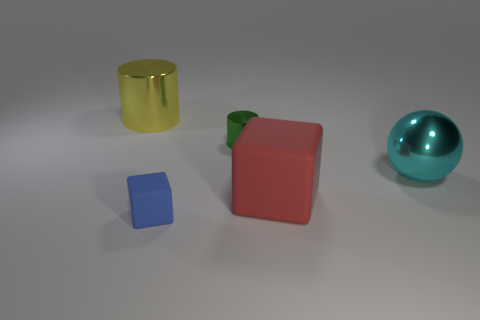Add 2 green metallic things. How many objects exist? 7 Subtract all cubes. How many objects are left? 3 Add 4 red rubber objects. How many red rubber objects exist? 5 Subtract 1 green cylinders. How many objects are left? 4 Subtract all large yellow metal cylinders. Subtract all big red objects. How many objects are left? 3 Add 1 big yellow things. How many big yellow things are left? 2 